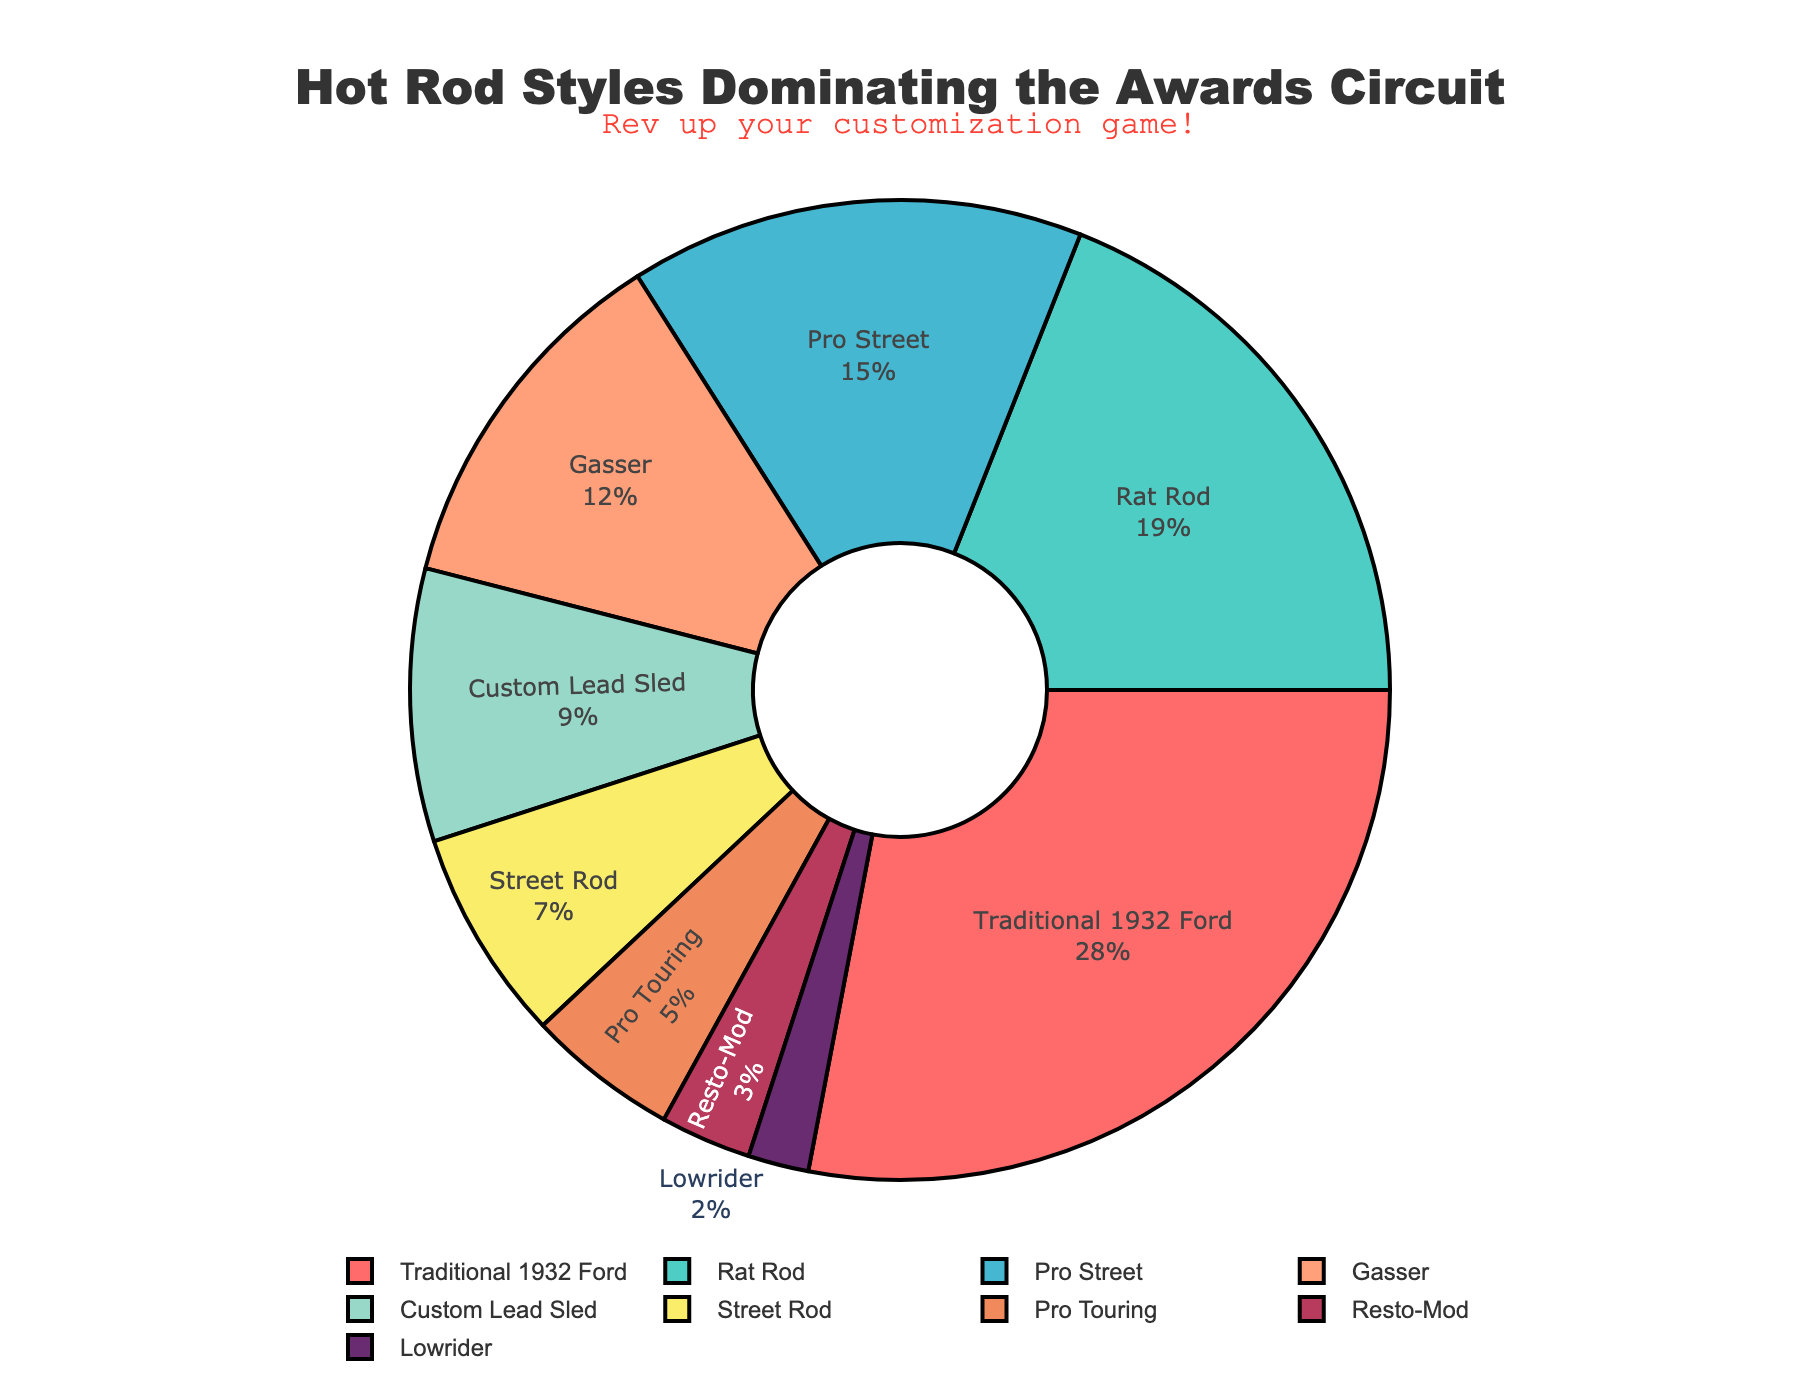Which hot rod style has won the highest percentage of awards? The chart shows various hot rod styles with their respective percentages of awards. The "Traditional 1932 Ford" segment is the largest in size, indicating it has won the highest percentage.
Answer: Traditional 1932 Ford How much more percentage of awards has the Traditional 1932 Ford won compared to the Rat Rod? The Traditional 1932 Ford has 28% and the Rat Rod has 19%. Subtracting these gives the difference: 28% - 19% = 9%.
Answer: 9% What is the combined percentage of awards for Pro Street and Gasser styles? The chart shows Pro Street has 15% and Gasser has 12%. Adding these gives the combined percentage: 15% + 12% = 27%.
Answer: 27% How many types of hot rod styles have won less than 10% of awards each? The chart shows Custom Lead Sled (9%), Street Rod (7%), Pro Touring (5%), Resto-Mod (3%), and Lowrider (2%) all have less than 10%. Counting these gives 5 styles.
Answer: 5 Which hot rod style has the smallest percentage of awards, and what is that percentage? The chart shows the Lowrider segment is the smallest, indicating it has the lowest percentage. The percentage is 2%.
Answer: Lowrider, 2% Compare the total percentage of awards won by Custom Lead Sled and Street Rod styles with the percentage won by Rat Rod. Which is greater and by how much? Custom Lead Sled has 9% and Street Rod has 7%, combined they have 16%. Rat Rod has 19%. Subtracting these shows Rat Rod has a greater percentage by 19% - 16% = 3%.
Answer: Rat Rod, 3% Is the percentage of awards won by the Pro Street style greater or less than the combined percentage of Pro Touring and Resto-Mod styles? Pro Street has 15%. Pro Touring has 5% and Resto-Mod has 3%, combined they have 5% + 3% = 8%. Pro Street's percentage is greater.
Answer: Greater What is the difference in the percentage of awards between the Gasser and Street Rod styles? The Gasser has 12% and the Street Rod has 7%. Subtracting these gives the difference: 12% - 7% = 5%.
Answer: 5% Which styles together constitute more than half of the total awards? Traditional 1932 Ford, Rat Rod, and Pro Street together have 28% + 19% + 15% = 62%, which is more than half.
Answer: Traditional 1932 Ford, Rat Rod, Pro Street 